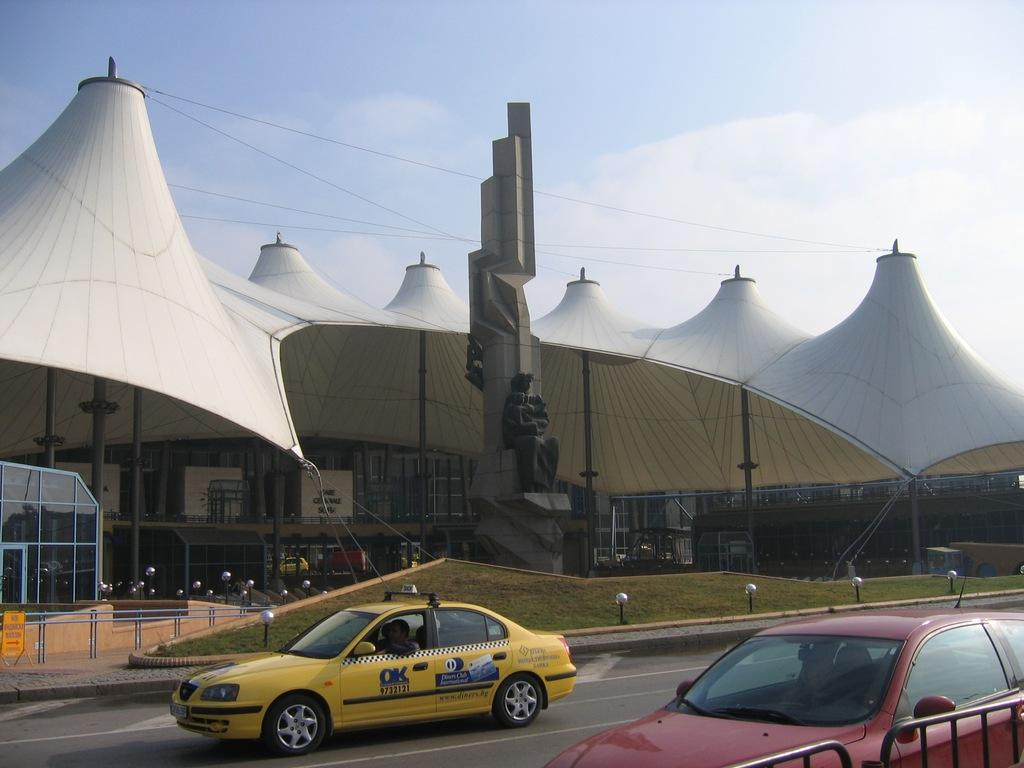<image>
Summarize the visual content of the image. Taxi Cab that says OK and Diners Club along with a Red Car that is parked on the side of a building. 